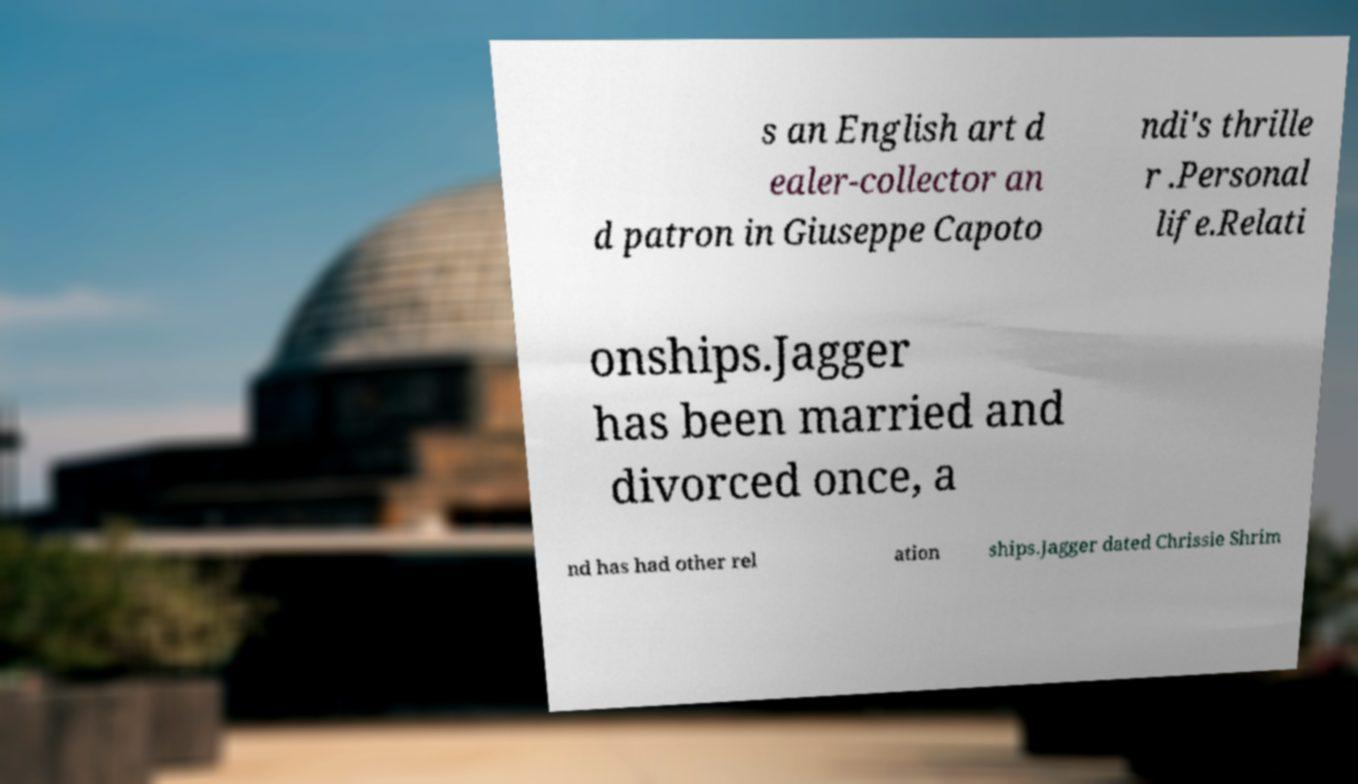Can you read and provide the text displayed in the image?This photo seems to have some interesting text. Can you extract and type it out for me? s an English art d ealer-collector an d patron in Giuseppe Capoto ndi's thrille r .Personal life.Relati onships.Jagger has been married and divorced once, a nd has had other rel ation ships.Jagger dated Chrissie Shrim 